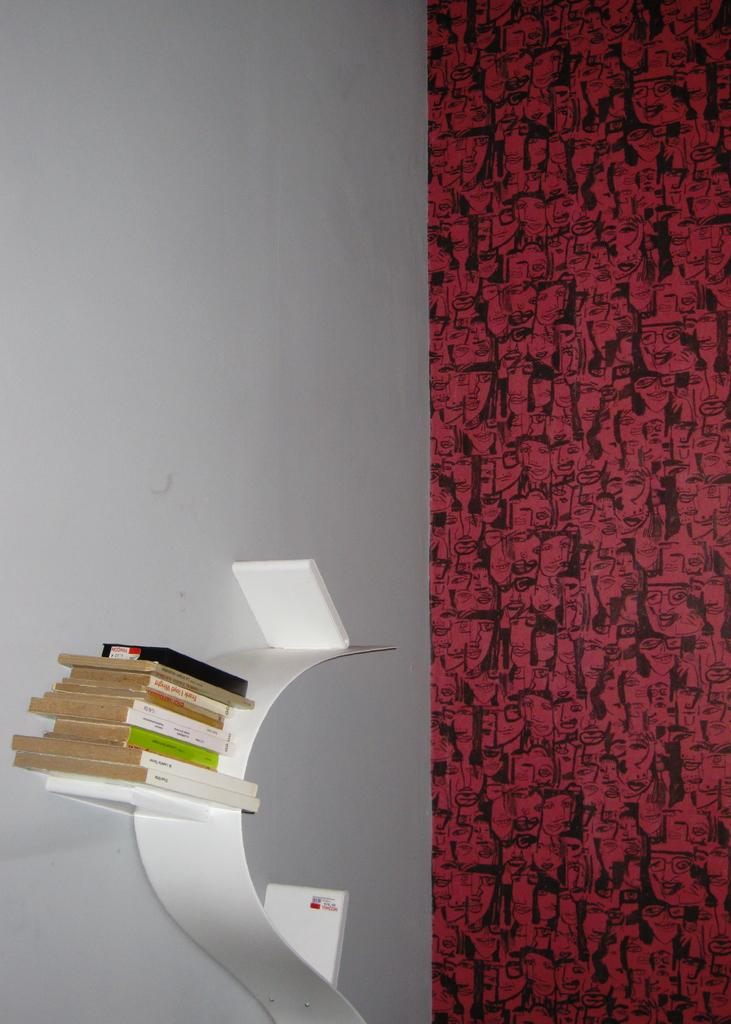What objects are present in the image? There are books in the image. Where are the books located? The books are on a white object attached to the wall. Can you describe the wall in the image? There is a red and black color design on the wall. What type of bean is depicted in the image? There are no beans present in the image; it features books on a white object attached to the wall and a red and black color design on the wall. What type of prose can be seen written on the books in the image? There is no prose visible on the books in the image, as the focus is on the books' presence and location. 